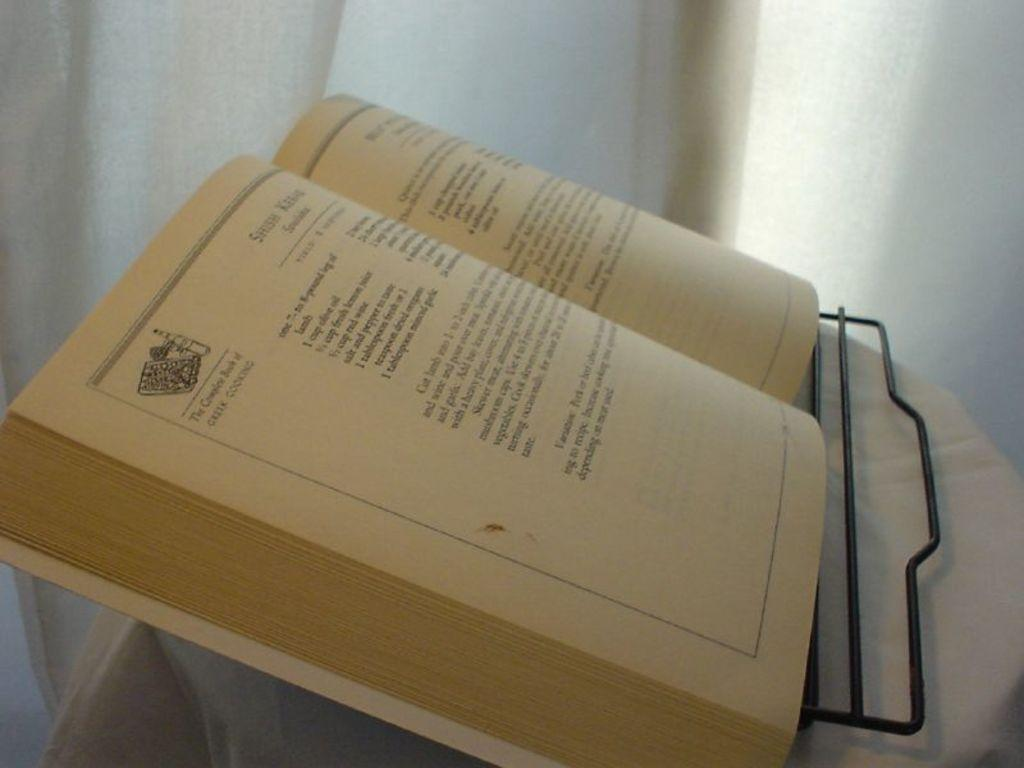Provide a one-sentence caption for the provided image. A recipe book called The Complete Book of Greek Cooking. 